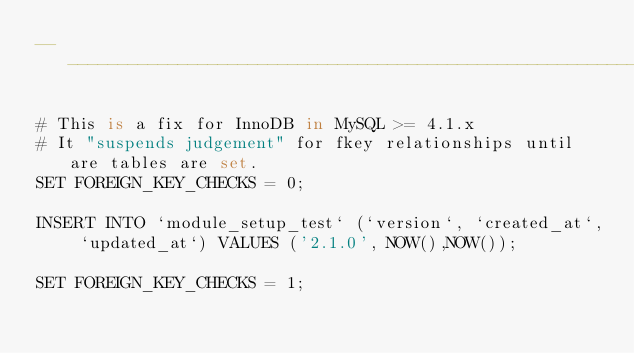Convert code to text. <code><loc_0><loc_0><loc_500><loc_500><_SQL_>-- ---------------------------------------------------------------------

# This is a fix for InnoDB in MySQL >= 4.1.x
# It "suspends judgement" for fkey relationships until are tables are set.
SET FOREIGN_KEY_CHECKS = 0;

INSERT INTO `module_setup_test` (`version`, `created_at`, `updated_at`) VALUES ('2.1.0', NOW(),NOW());

SET FOREIGN_KEY_CHECKS = 1;</code> 